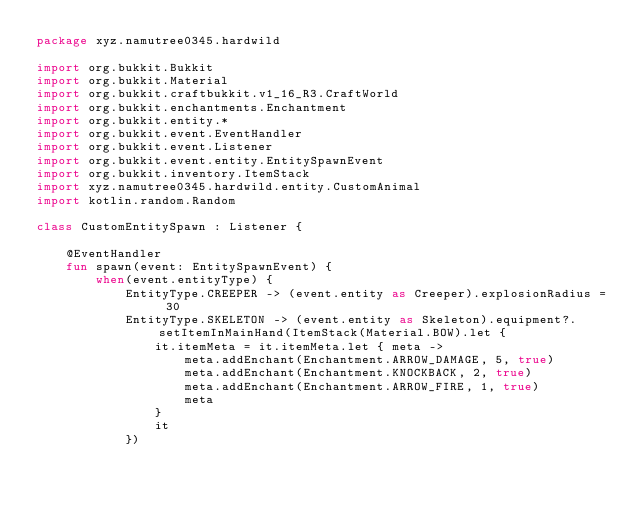Convert code to text. <code><loc_0><loc_0><loc_500><loc_500><_Kotlin_>package xyz.namutree0345.hardwild

import org.bukkit.Bukkit
import org.bukkit.Material
import org.bukkit.craftbukkit.v1_16_R3.CraftWorld
import org.bukkit.enchantments.Enchantment
import org.bukkit.entity.*
import org.bukkit.event.EventHandler
import org.bukkit.event.Listener
import org.bukkit.event.entity.EntitySpawnEvent
import org.bukkit.inventory.ItemStack
import xyz.namutree0345.hardwild.entity.CustomAnimal
import kotlin.random.Random

class CustomEntitySpawn : Listener {

    @EventHandler
    fun spawn(event: EntitySpawnEvent) {
        when(event.entityType) {
            EntityType.CREEPER -> (event.entity as Creeper).explosionRadius = 30
            EntityType.SKELETON -> (event.entity as Skeleton).equipment?.setItemInMainHand(ItemStack(Material.BOW).let {
                it.itemMeta = it.itemMeta.let { meta ->
                    meta.addEnchant(Enchantment.ARROW_DAMAGE, 5, true)
                    meta.addEnchant(Enchantment.KNOCKBACK, 2, true)
                    meta.addEnchant(Enchantment.ARROW_FIRE, 1, true)
                    meta
                }
                it
            })</code> 